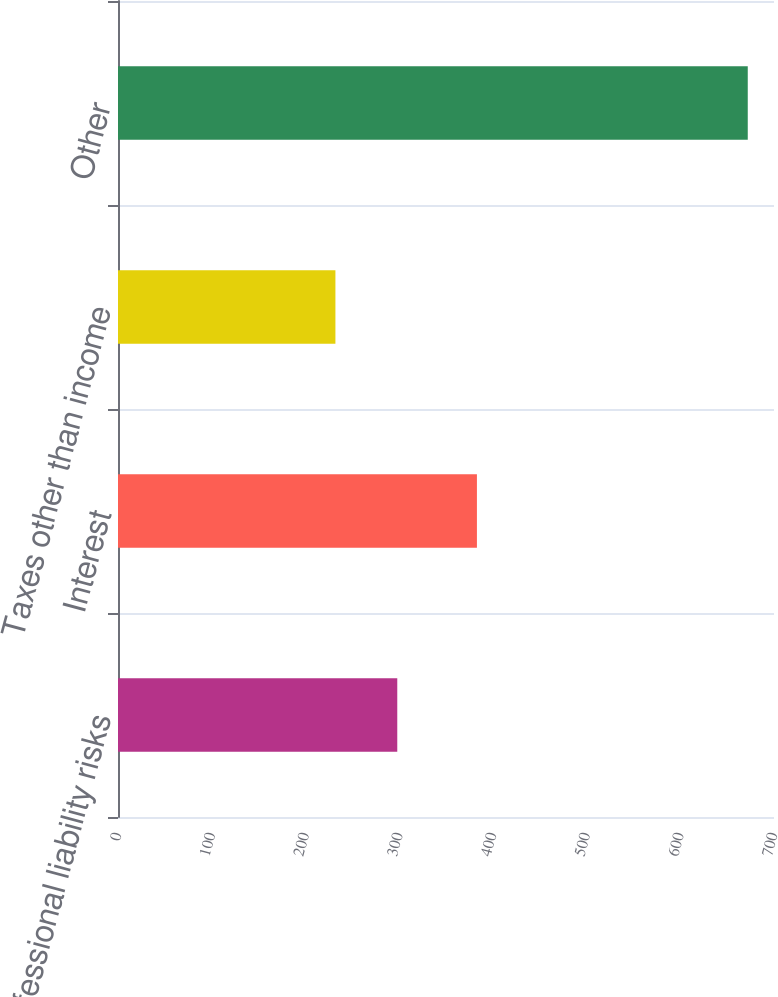Convert chart to OTSL. <chart><loc_0><loc_0><loc_500><loc_500><bar_chart><fcel>Professional liability risks<fcel>Interest<fcel>Taxes other than income<fcel>Other<nl><fcel>298<fcel>383<fcel>232<fcel>672<nl></chart> 